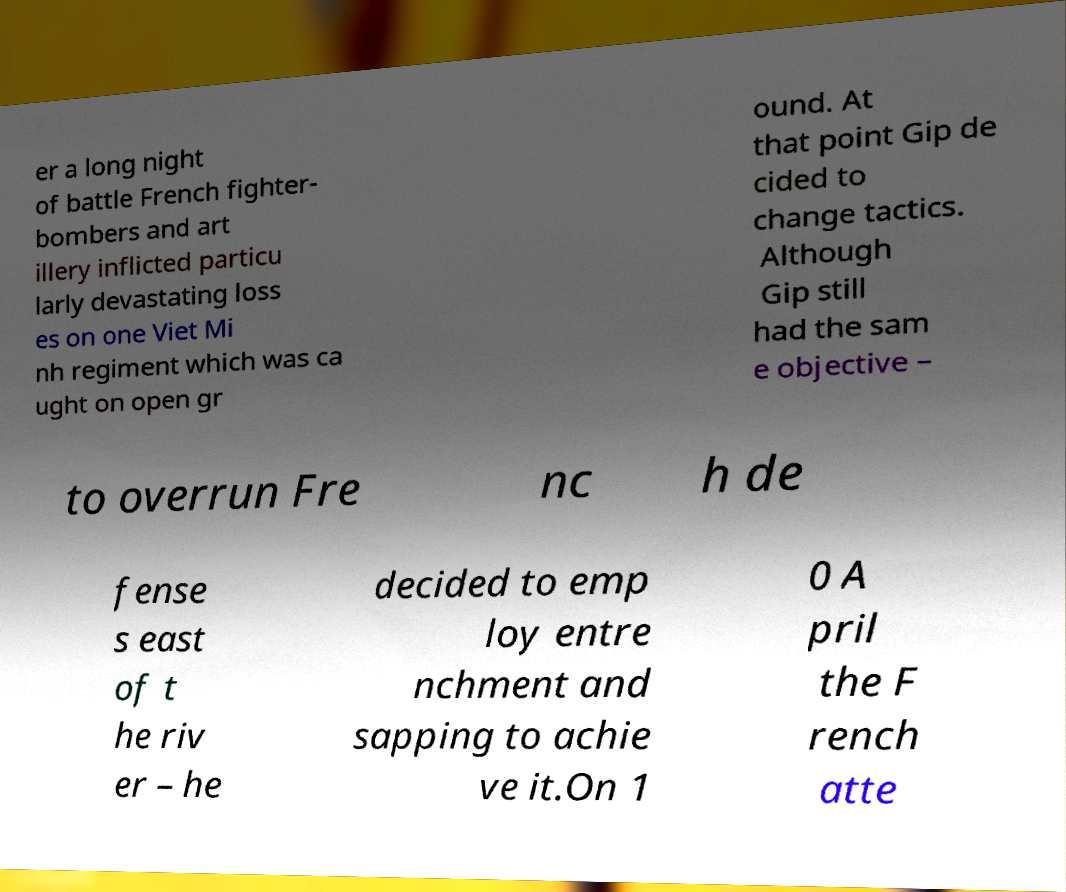Could you assist in decoding the text presented in this image and type it out clearly? er a long night of battle French fighter- bombers and art illery inflicted particu larly devastating loss es on one Viet Mi nh regiment which was ca ught on open gr ound. At that point Gip de cided to change tactics. Although Gip still had the sam e objective – to overrun Fre nc h de fense s east of t he riv er – he decided to emp loy entre nchment and sapping to achie ve it.On 1 0 A pril the F rench atte 